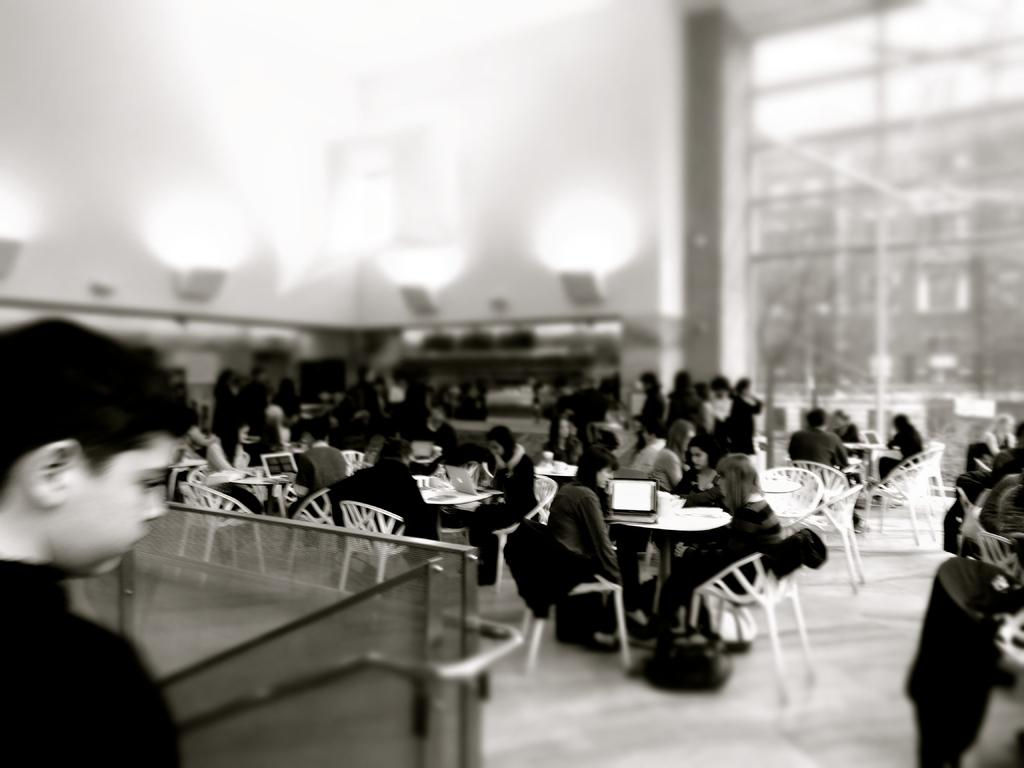What is happening with the groups of people in the image? The people are sitting around tables and working. Can you describe the setting of the image? The background is blurred, and there are groups of people sitting around tables. Is there any specific individual mentioned in the facts? Yes, there is a boy on the left side of the image. What type of tank can be seen in the image? There is no tank present in the image. What color is the marble on the right side of the image? There is no marble present in the image. 